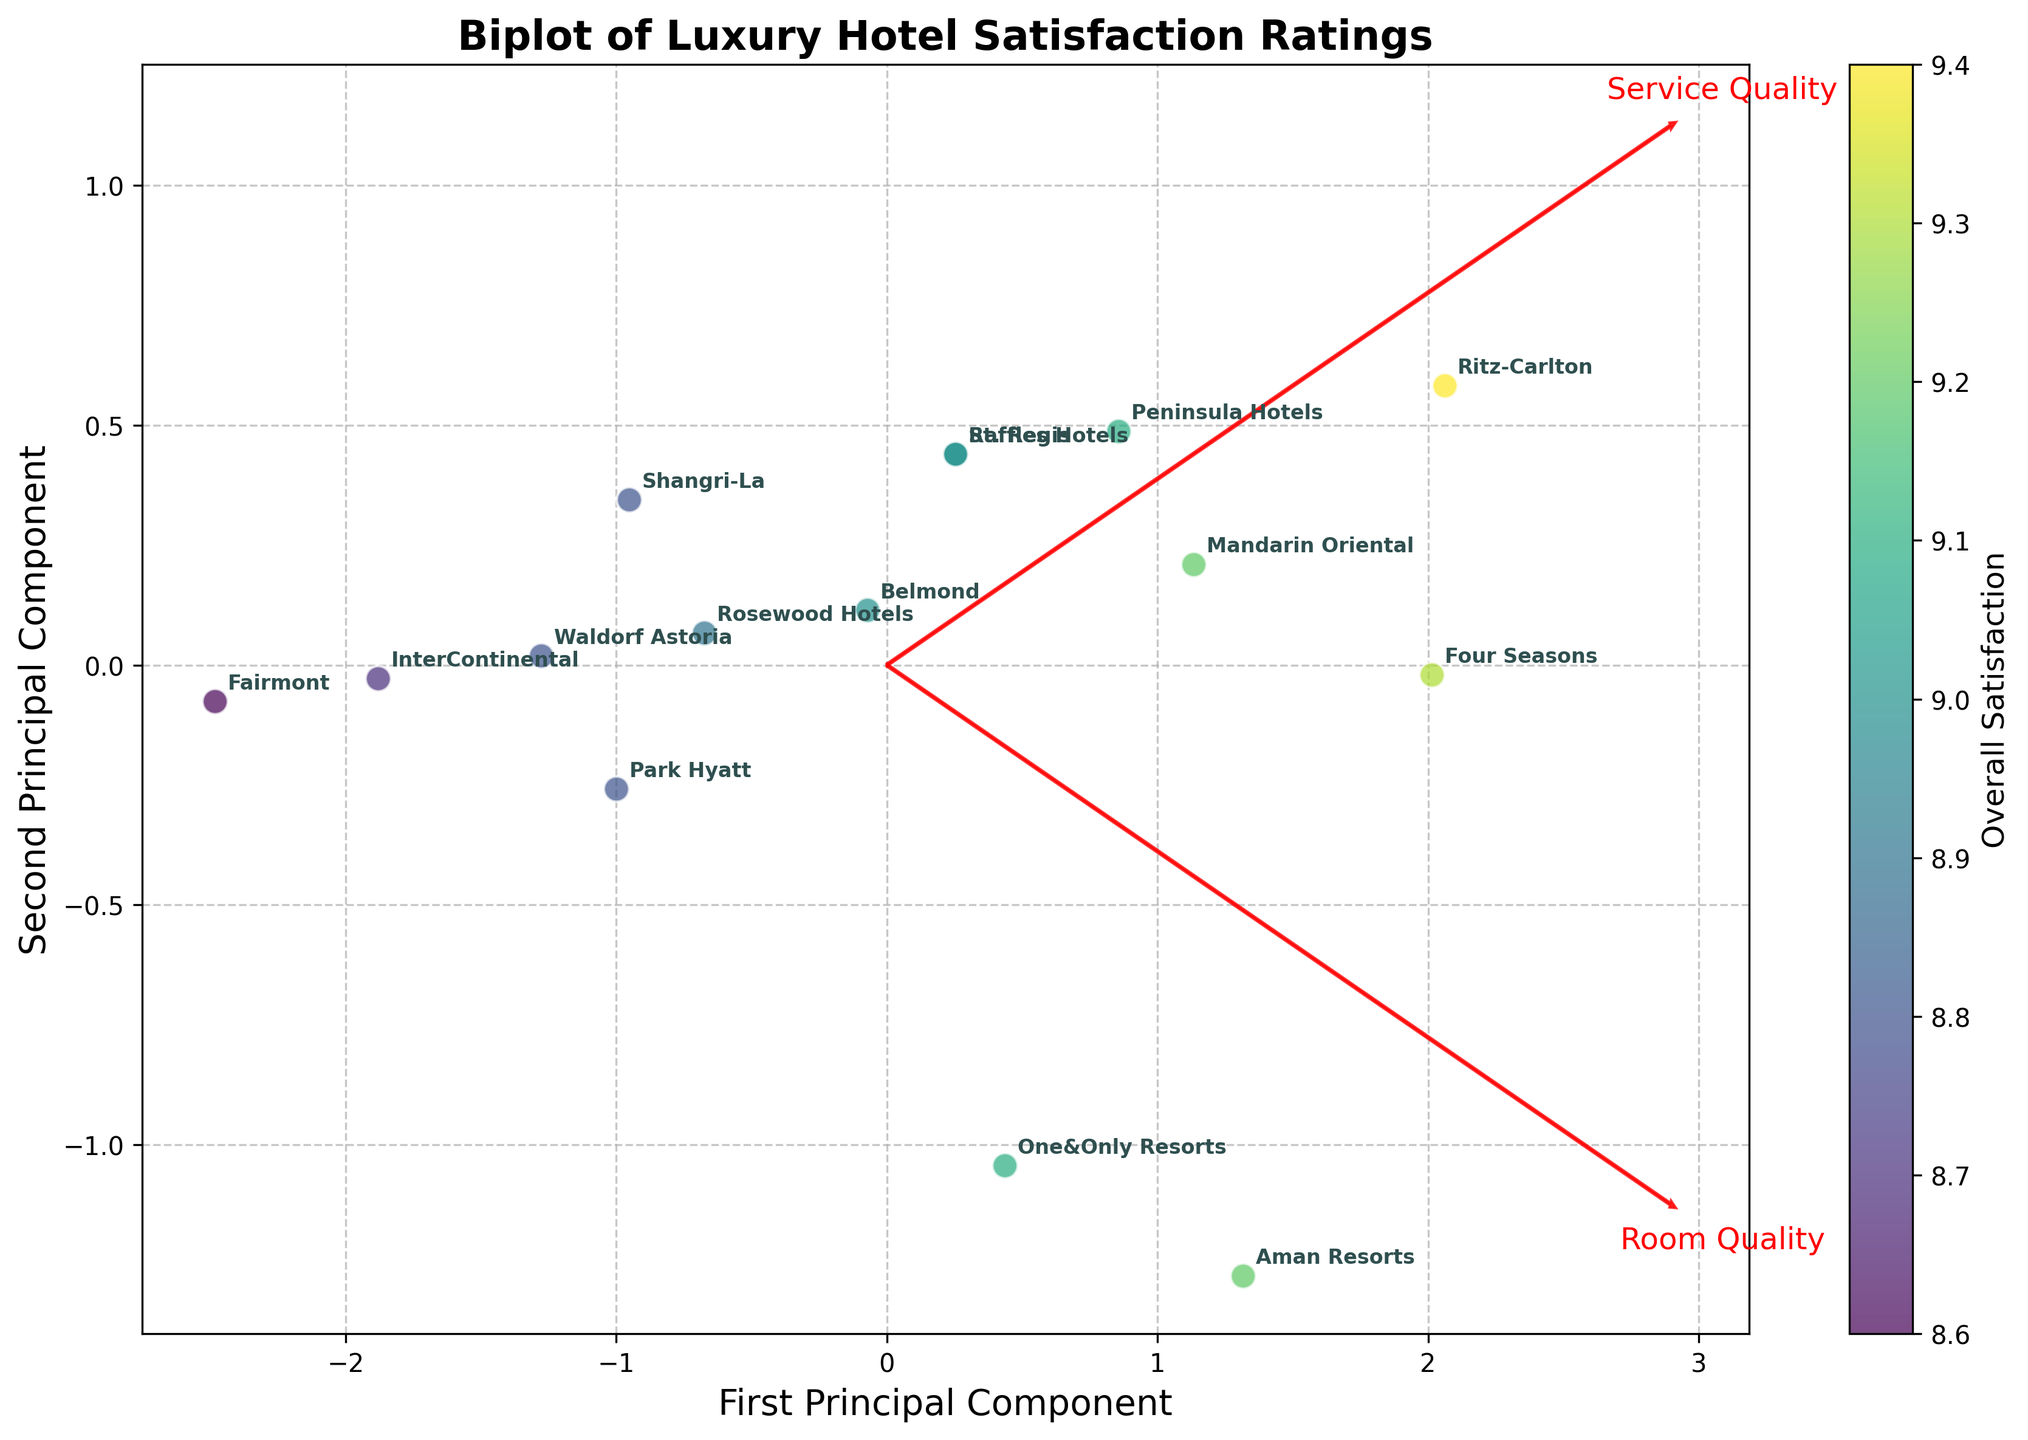What is the title of the plot? The title of the plot is written at the top and usually provides a brief description of what the figure represents. In this case, it is "Biplot of Luxury Hotel Satisfaction Ratings".
Answer: Biplot of Luxury Hotel Satisfaction Ratings What are the axes labels of the plot? The axes labels are indicated on the horizontal and vertical axes. In this plot, the x-axis is labeled 'First Principal Component', and the y-axis is labeled 'Second Principal Component'.
Answer: First Principal Component; Second Principal Component Which hotel has the highest overall satisfaction rating? The color intensity in the scatter plot represents the overall satisfaction rating. The hotel with the brightest color has the highest rating. Ritz-Carlton stands out with the highest intensity.
Answer: Ritz-Carlton Which variables are represented by the red arrows in the plot? The red arrows in the biplot show the direction and magnitude of the variables contributing to the principal components. In this case, the arrows represent 'Room Quality' and 'Service Quality'.
Answer: Room Quality; Service Quality Which hotel is closest to the origin in the plot? The origin in a PCA plot typically signifies the average values of the standardized features. The hotel closest to (0,0) on the plot is Shangri-La.
Answer: Shangri-La How does the position of Ritz-Carlton relate to room quality and service quality? Ritz-Carlton is located in the region aligned with high values for both 'Room Quality' and 'Service Quality' as indicated by the red arrows pointing in that direction.
Answer: High room and service quality Compare the first principal component for Four Seasons and Fairmont. Which one has a larger value? Looking at the positions on the x-axis (First Principal Component), Four Seasons is further to the right compared to Fairmont, indicating a larger value.
Answer: Four Seasons What hotel has the lowest rating for room quality based on its PCA score? The PCA scores can be inferred from the projection on the 'Room Quality' loading vector. InterContinental is the furthest from the arrow indicating low room quality.
Answer: InterContinental Which two hotels are the most similar in terms of room quality and service quality? The closeness of the points in the biplot indicates similarity in terms of the principal components derived from 'Room Quality' and 'Service Quality'. Raffles Hotels and St. Regis are closely grouped.
Answer: Raffles Hotels and St. Regis 